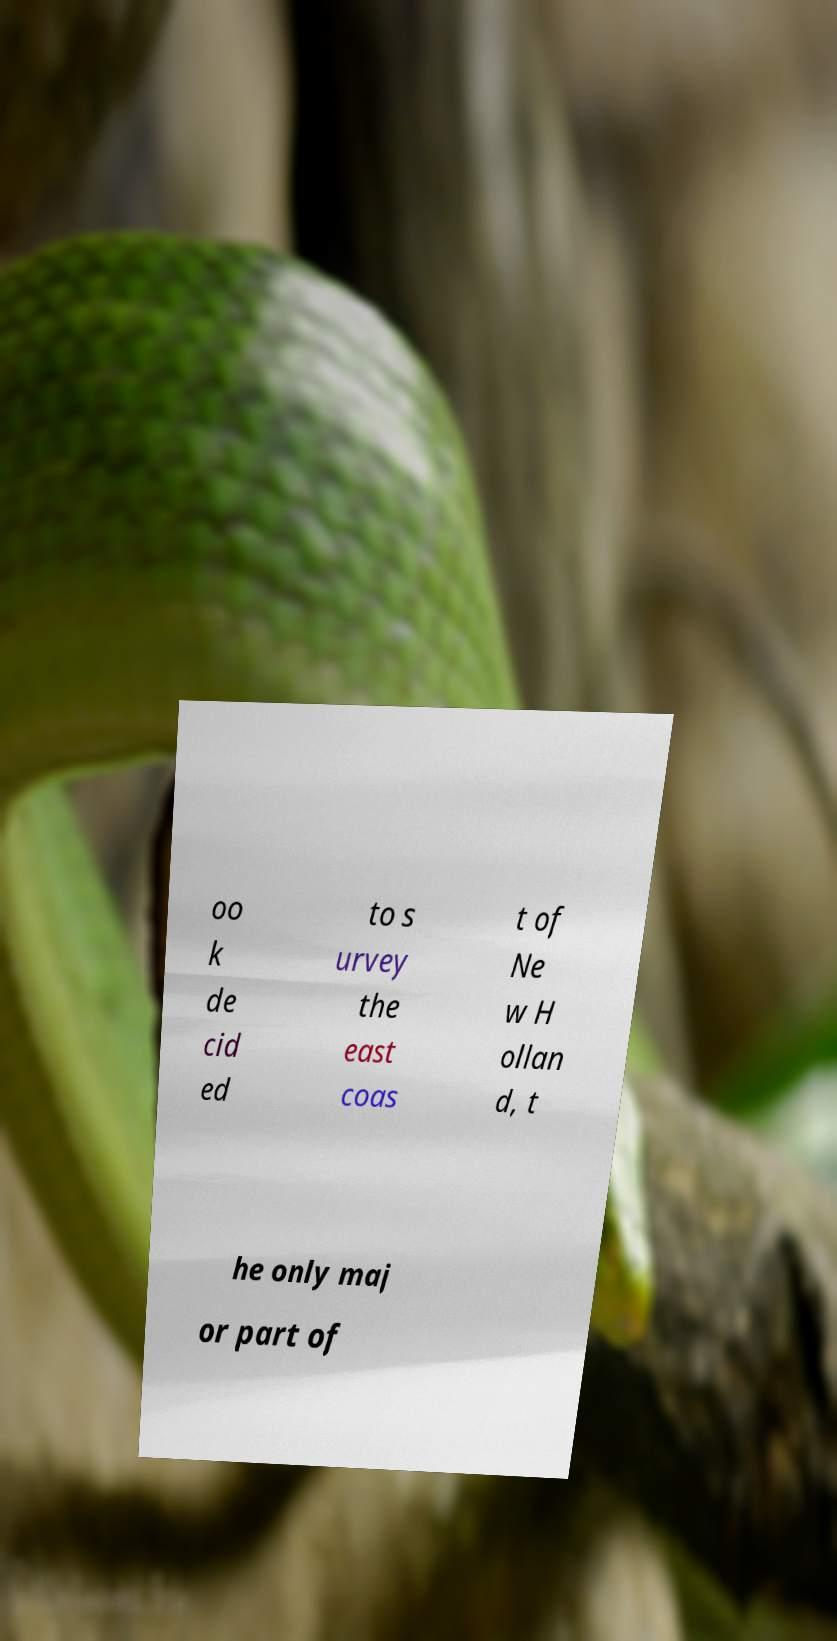I need the written content from this picture converted into text. Can you do that? oo k de cid ed to s urvey the east coas t of Ne w H ollan d, t he only maj or part of 